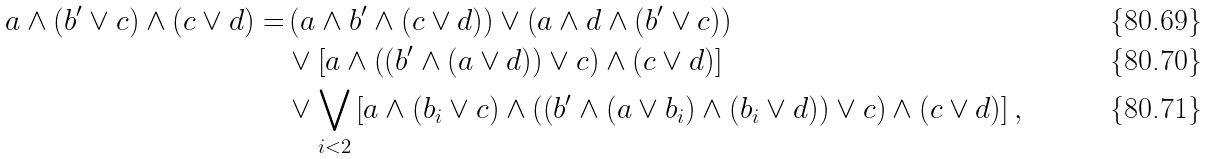<formula> <loc_0><loc_0><loc_500><loc_500>a \wedge ( b ^ { \prime } \vee c ) \wedge ( c \vee d ) = & \left ( a \wedge b ^ { \prime } \wedge ( c \vee d ) \right ) \vee \left ( a \wedge d \wedge ( b ^ { \prime } \vee c ) \right ) \\ & \vee \left [ a \wedge \left ( \left ( b ^ { \prime } \wedge ( a \vee d ) \right ) \vee c \right ) \wedge ( c \vee d ) \right ] \\ & \vee \bigvee _ { i < 2 } \left [ a \wedge ( b _ { i } \vee c ) \wedge \left ( \left ( b ^ { \prime } \wedge ( a \vee b _ { i } ) \wedge ( b _ { i } \vee d ) \right ) \vee c \right ) \wedge ( c \vee d ) \right ] ,</formula> 